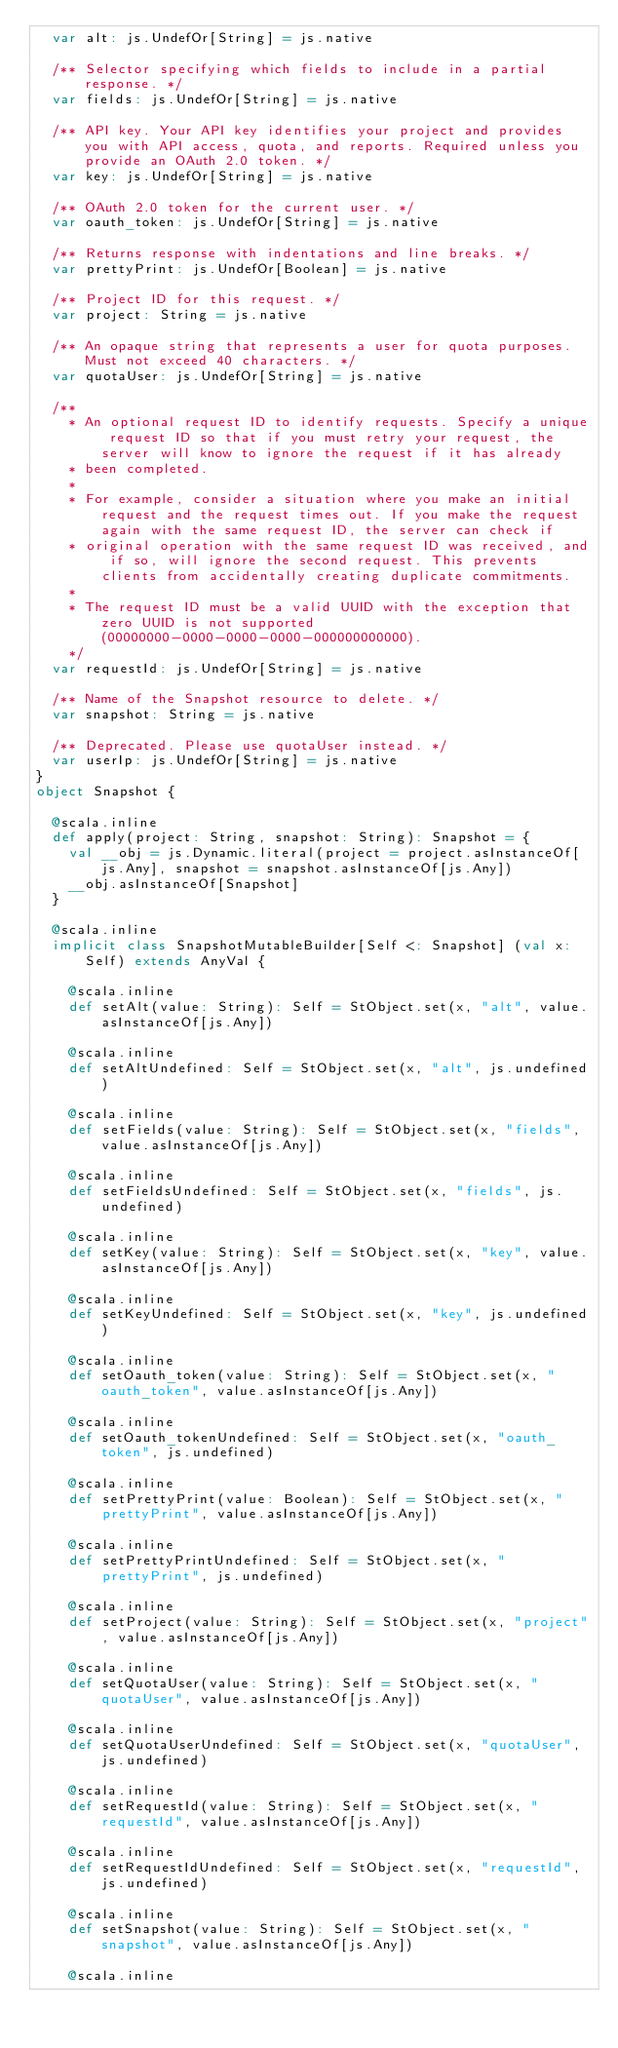Convert code to text. <code><loc_0><loc_0><loc_500><loc_500><_Scala_>  var alt: js.UndefOr[String] = js.native
  
  /** Selector specifying which fields to include in a partial response. */
  var fields: js.UndefOr[String] = js.native
  
  /** API key. Your API key identifies your project and provides you with API access, quota, and reports. Required unless you provide an OAuth 2.0 token. */
  var key: js.UndefOr[String] = js.native
  
  /** OAuth 2.0 token for the current user. */
  var oauth_token: js.UndefOr[String] = js.native
  
  /** Returns response with indentations and line breaks. */
  var prettyPrint: js.UndefOr[Boolean] = js.native
  
  /** Project ID for this request. */
  var project: String = js.native
  
  /** An opaque string that represents a user for quota purposes. Must not exceed 40 characters. */
  var quotaUser: js.UndefOr[String] = js.native
  
  /**
    * An optional request ID to identify requests. Specify a unique request ID so that if you must retry your request, the server will know to ignore the request if it has already
    * been completed.
    *
    * For example, consider a situation where you make an initial request and the request times out. If you make the request again with the same request ID, the server can check if
    * original operation with the same request ID was received, and if so, will ignore the second request. This prevents clients from accidentally creating duplicate commitments.
    *
    * The request ID must be a valid UUID with the exception that zero UUID is not supported (00000000-0000-0000-0000-000000000000).
    */
  var requestId: js.UndefOr[String] = js.native
  
  /** Name of the Snapshot resource to delete. */
  var snapshot: String = js.native
  
  /** Deprecated. Please use quotaUser instead. */
  var userIp: js.UndefOr[String] = js.native
}
object Snapshot {
  
  @scala.inline
  def apply(project: String, snapshot: String): Snapshot = {
    val __obj = js.Dynamic.literal(project = project.asInstanceOf[js.Any], snapshot = snapshot.asInstanceOf[js.Any])
    __obj.asInstanceOf[Snapshot]
  }
  
  @scala.inline
  implicit class SnapshotMutableBuilder[Self <: Snapshot] (val x: Self) extends AnyVal {
    
    @scala.inline
    def setAlt(value: String): Self = StObject.set(x, "alt", value.asInstanceOf[js.Any])
    
    @scala.inline
    def setAltUndefined: Self = StObject.set(x, "alt", js.undefined)
    
    @scala.inline
    def setFields(value: String): Self = StObject.set(x, "fields", value.asInstanceOf[js.Any])
    
    @scala.inline
    def setFieldsUndefined: Self = StObject.set(x, "fields", js.undefined)
    
    @scala.inline
    def setKey(value: String): Self = StObject.set(x, "key", value.asInstanceOf[js.Any])
    
    @scala.inline
    def setKeyUndefined: Self = StObject.set(x, "key", js.undefined)
    
    @scala.inline
    def setOauth_token(value: String): Self = StObject.set(x, "oauth_token", value.asInstanceOf[js.Any])
    
    @scala.inline
    def setOauth_tokenUndefined: Self = StObject.set(x, "oauth_token", js.undefined)
    
    @scala.inline
    def setPrettyPrint(value: Boolean): Self = StObject.set(x, "prettyPrint", value.asInstanceOf[js.Any])
    
    @scala.inline
    def setPrettyPrintUndefined: Self = StObject.set(x, "prettyPrint", js.undefined)
    
    @scala.inline
    def setProject(value: String): Self = StObject.set(x, "project", value.asInstanceOf[js.Any])
    
    @scala.inline
    def setQuotaUser(value: String): Self = StObject.set(x, "quotaUser", value.asInstanceOf[js.Any])
    
    @scala.inline
    def setQuotaUserUndefined: Self = StObject.set(x, "quotaUser", js.undefined)
    
    @scala.inline
    def setRequestId(value: String): Self = StObject.set(x, "requestId", value.asInstanceOf[js.Any])
    
    @scala.inline
    def setRequestIdUndefined: Self = StObject.set(x, "requestId", js.undefined)
    
    @scala.inline
    def setSnapshot(value: String): Self = StObject.set(x, "snapshot", value.asInstanceOf[js.Any])
    
    @scala.inline</code> 